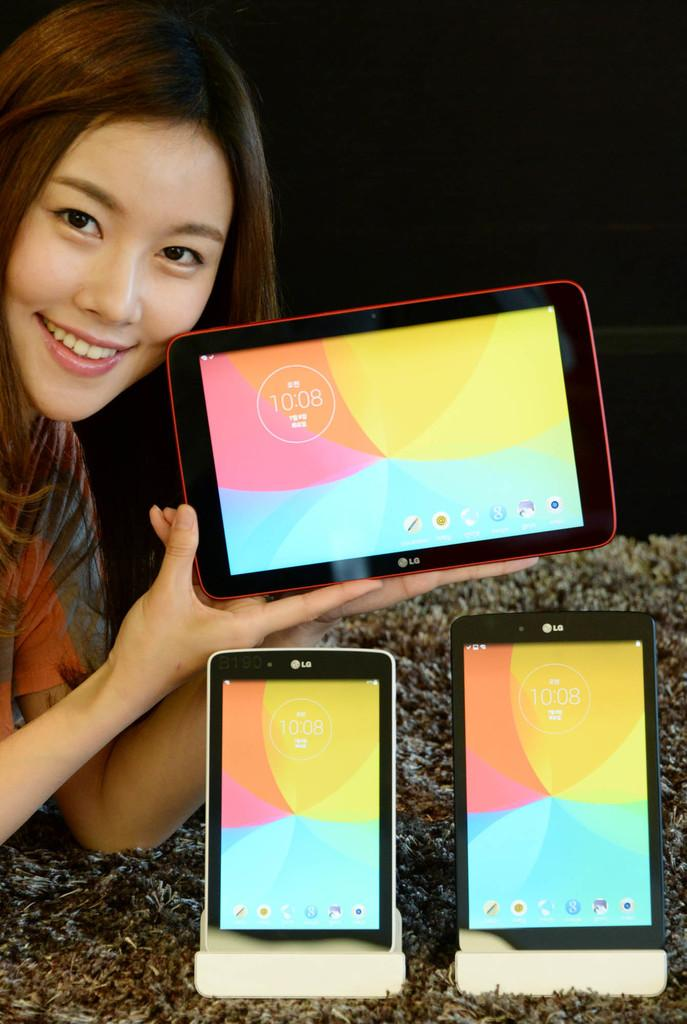Who is the main subject in the image? There is a girl in the image. Where is the girl located in the image? The girl is on the left side of the image. What is the girl holding in her hand? The girl is holding a tablet in her hand. What else can be seen on the table in the image? There are two tablets on the table in the image. What type of disgust can be seen on the girl's face in the image? There is no indication of disgust on the girl's face in the image. What is the girl using to cut the tablets in the image? There is no cutting or scissors present in the image; the girl is simply holding a tablet. 